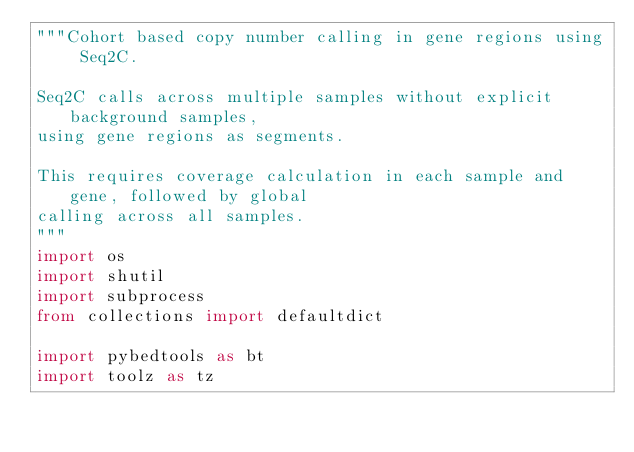<code> <loc_0><loc_0><loc_500><loc_500><_Python_>"""Cohort based copy number calling in gene regions using Seq2C.

Seq2C calls across multiple samples without explicit background samples,
using gene regions as segments.

This requires coverage calculation in each sample and gene, followed by global
calling across all samples.
"""
import os
import shutil
import subprocess
from collections import defaultdict

import pybedtools as bt
import toolz as tz
</code> 